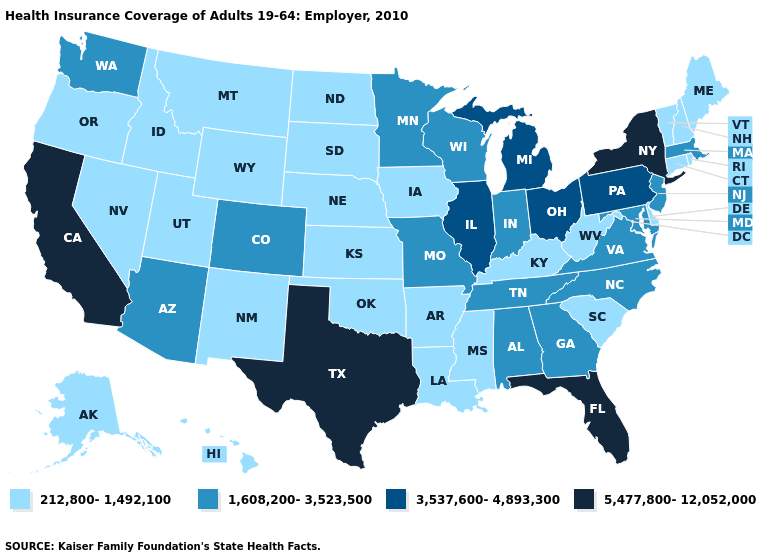Name the states that have a value in the range 1,608,200-3,523,500?
Answer briefly. Alabama, Arizona, Colorado, Georgia, Indiana, Maryland, Massachusetts, Minnesota, Missouri, New Jersey, North Carolina, Tennessee, Virginia, Washington, Wisconsin. Does the first symbol in the legend represent the smallest category?
Quick response, please. Yes. What is the value of North Carolina?
Write a very short answer. 1,608,200-3,523,500. Which states have the highest value in the USA?
Be succinct. California, Florida, New York, Texas. What is the lowest value in the USA?
Keep it brief. 212,800-1,492,100. What is the lowest value in the West?
Short answer required. 212,800-1,492,100. How many symbols are there in the legend?
Write a very short answer. 4. Does Louisiana have a lower value than New York?
Short answer required. Yes. What is the highest value in the South ?
Give a very brief answer. 5,477,800-12,052,000. What is the value of Indiana?
Give a very brief answer. 1,608,200-3,523,500. How many symbols are there in the legend?
Give a very brief answer. 4. Does Hawaii have a lower value than Nebraska?
Be succinct. No. Name the states that have a value in the range 212,800-1,492,100?
Give a very brief answer. Alaska, Arkansas, Connecticut, Delaware, Hawaii, Idaho, Iowa, Kansas, Kentucky, Louisiana, Maine, Mississippi, Montana, Nebraska, Nevada, New Hampshire, New Mexico, North Dakota, Oklahoma, Oregon, Rhode Island, South Carolina, South Dakota, Utah, Vermont, West Virginia, Wyoming. Among the states that border South Dakota , does Minnesota have the highest value?
Write a very short answer. Yes. What is the value of Missouri?
Short answer required. 1,608,200-3,523,500. 